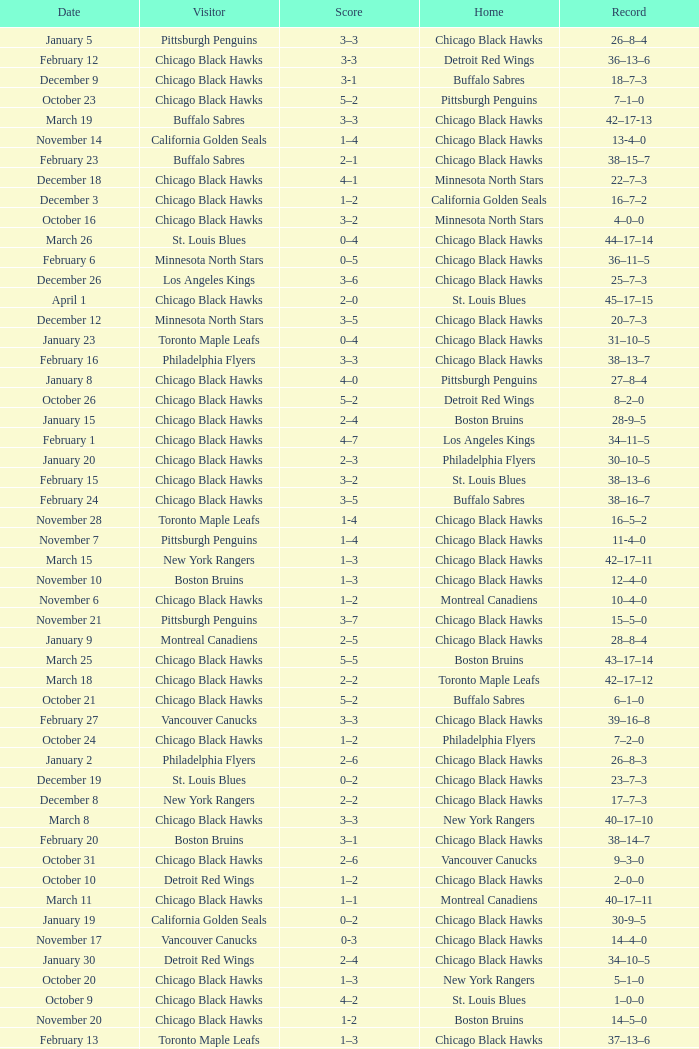What is the Score of the Chicago Black Hawks Home game with the Visiting Vancouver Canucks on November 17? 0-3. 